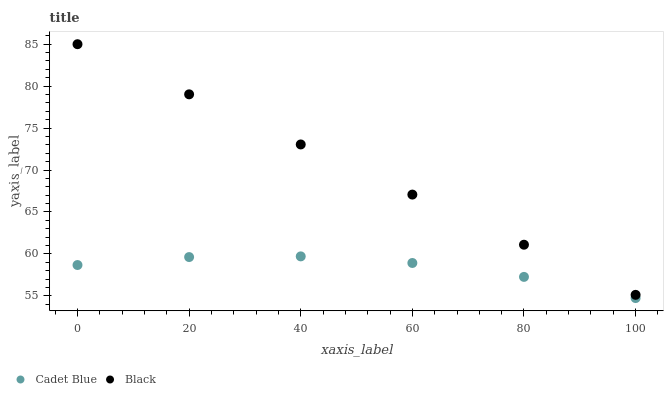Does Cadet Blue have the minimum area under the curve?
Answer yes or no. Yes. Does Black have the maximum area under the curve?
Answer yes or no. Yes. Does Black have the minimum area under the curve?
Answer yes or no. No. Is Black the smoothest?
Answer yes or no. Yes. Is Cadet Blue the roughest?
Answer yes or no. Yes. Is Black the roughest?
Answer yes or no. No. Does Cadet Blue have the lowest value?
Answer yes or no. Yes. Does Black have the lowest value?
Answer yes or no. No. Does Black have the highest value?
Answer yes or no. Yes. Is Cadet Blue less than Black?
Answer yes or no. Yes. Is Black greater than Cadet Blue?
Answer yes or no. Yes. Does Cadet Blue intersect Black?
Answer yes or no. No. 